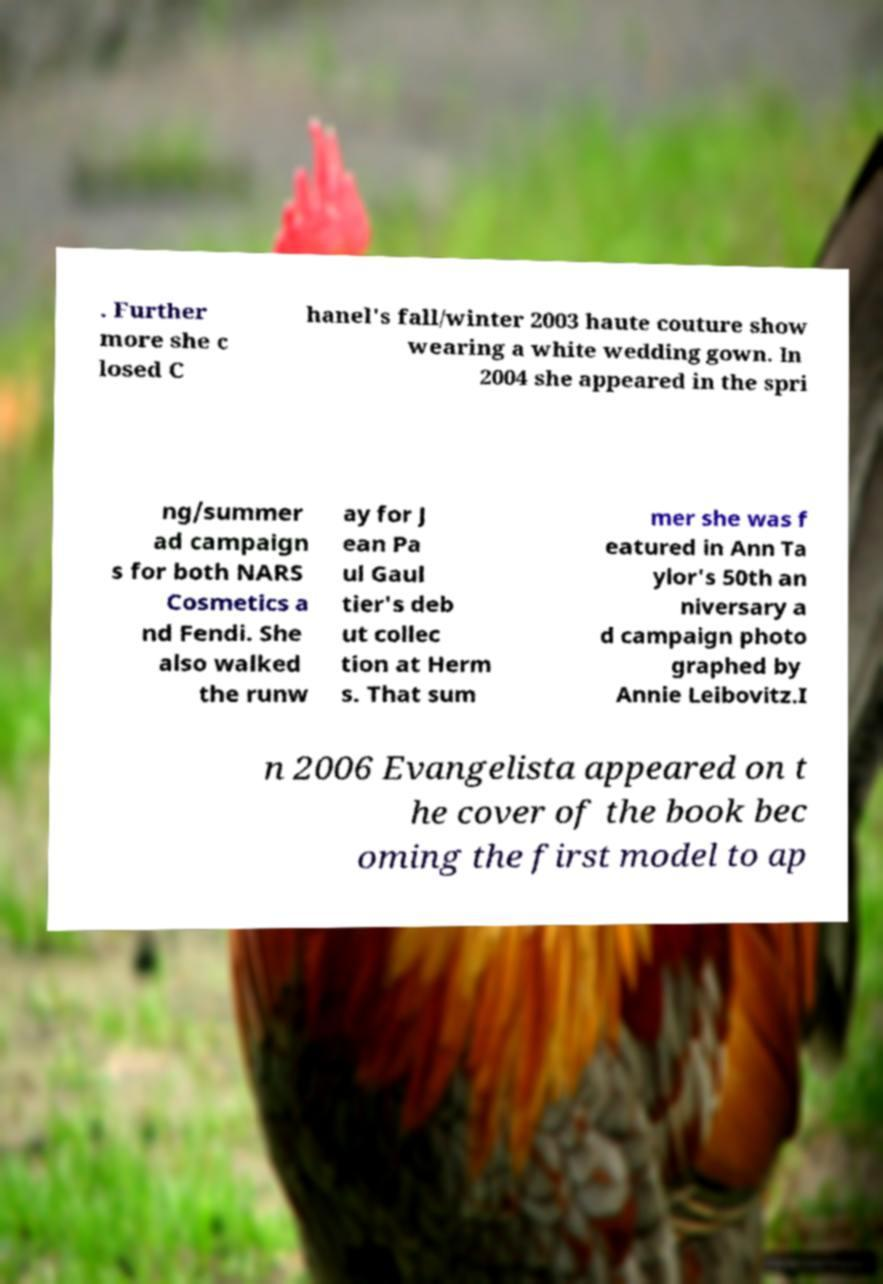Could you assist in decoding the text presented in this image and type it out clearly? . Further more she c losed C hanel's fall/winter 2003 haute couture show wearing a white wedding gown. In 2004 she appeared in the spri ng/summer ad campaign s for both NARS Cosmetics a nd Fendi. She also walked the runw ay for J ean Pa ul Gaul tier's deb ut collec tion at Herm s. That sum mer she was f eatured in Ann Ta ylor's 50th an niversary a d campaign photo graphed by Annie Leibovitz.I n 2006 Evangelista appeared on t he cover of the book bec oming the first model to ap 